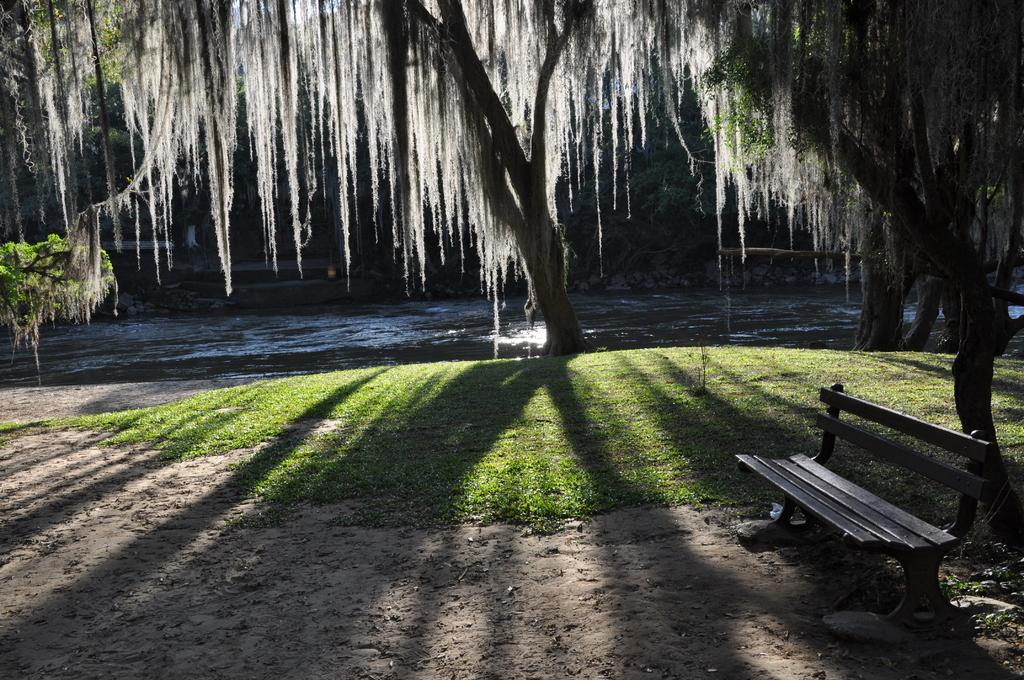What type of seating is located on the right side of the image? There is a bench on the right side of the image. Where is the bench positioned in relation to the ground? The bench is on the ground. What is near the bench in the image? There is a tree near the bench. What type of vegetation is present on the ground? Grass is present on the ground. What can be seen in the background of the image? There is a lake and trees in the background of the image. What type of disease is affecting the mass of people in the image? There are no people present in the image, so it is not possible to determine if any disease is affecting a mass of people. 